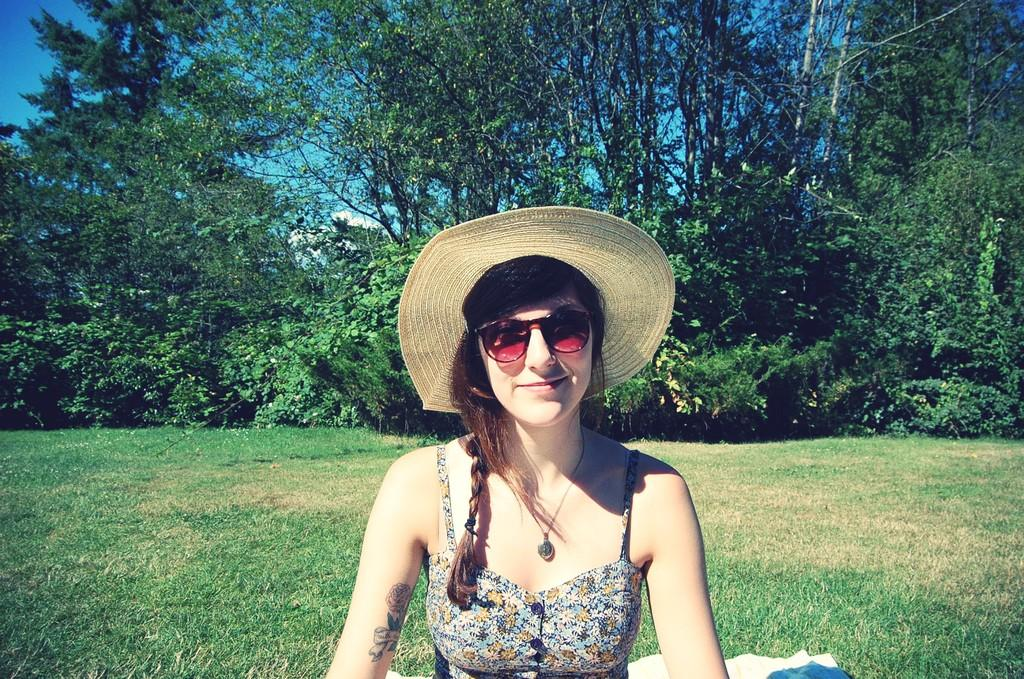Who is the main subject in the image? There is a girl in the image. What is the girl doing in the image? The girl is sitting on the grass. What can be seen in the background of the image? There are trees and the sky visible in the background of the image. How many horses are present in the image? There are no horses present in the image; it features a girl sitting on the grass with trees and the sky in the background. 